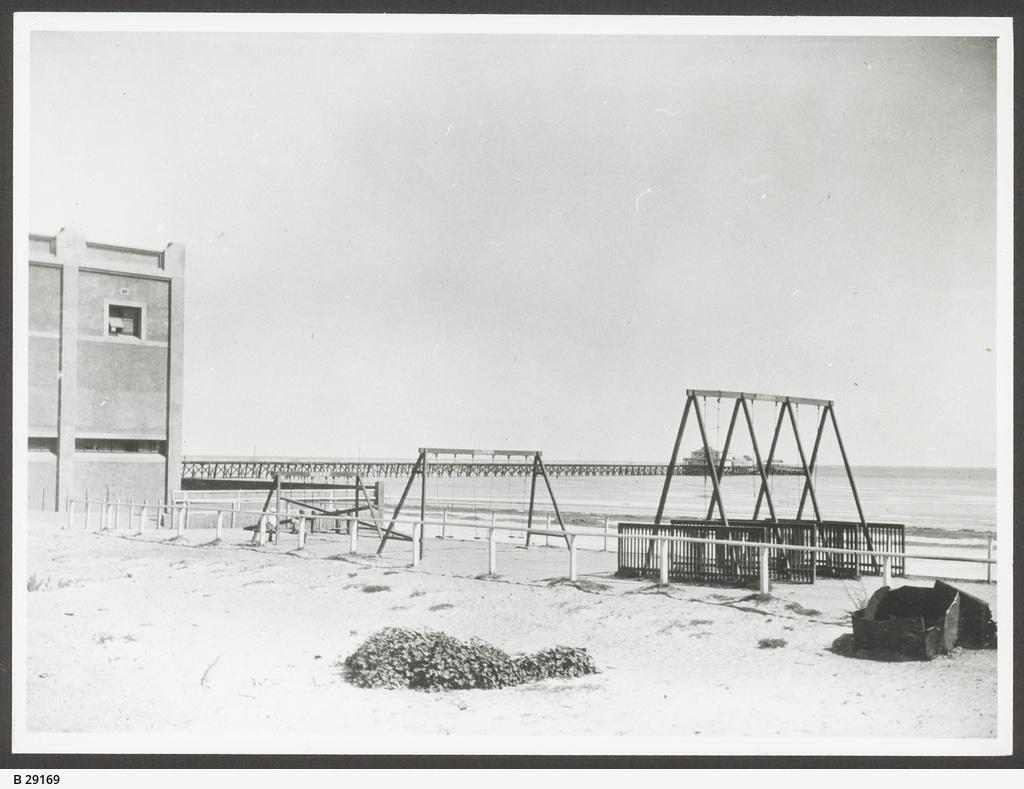Could you give a brief overview of what you see in this image? In this picture there are few rows which has few cradles attached to it and there is a building in the left corner and there is water and a bridge in the background. 